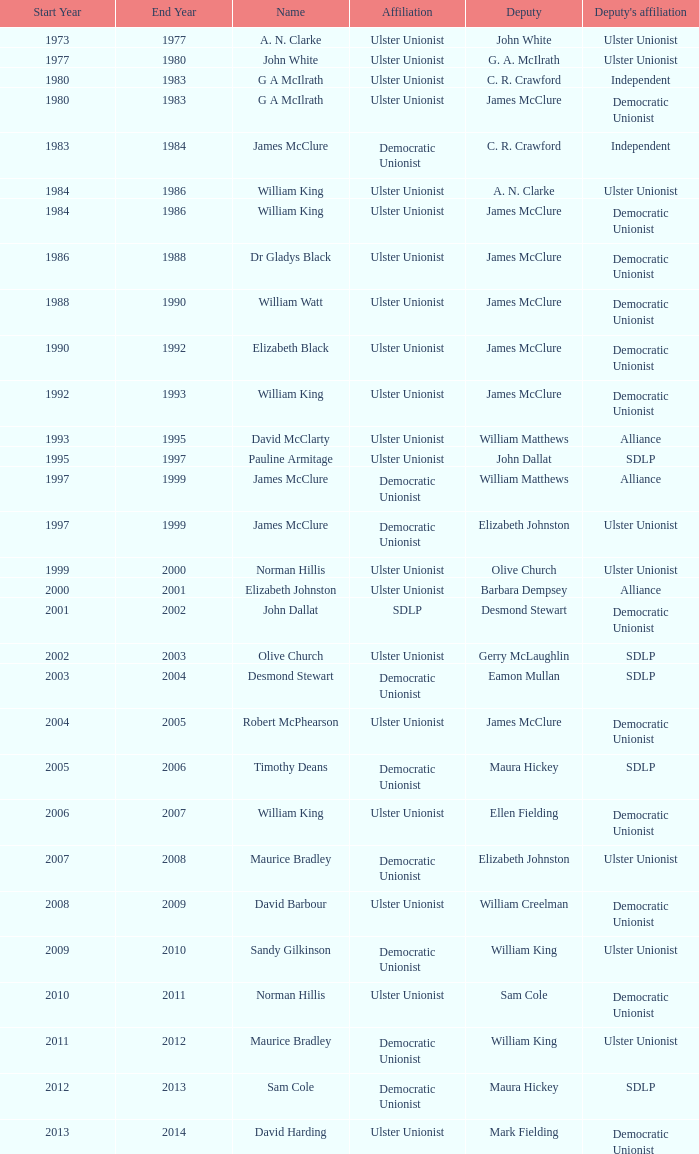What is the Political affiliation of deputy john dallat? Ulster Unionist. 